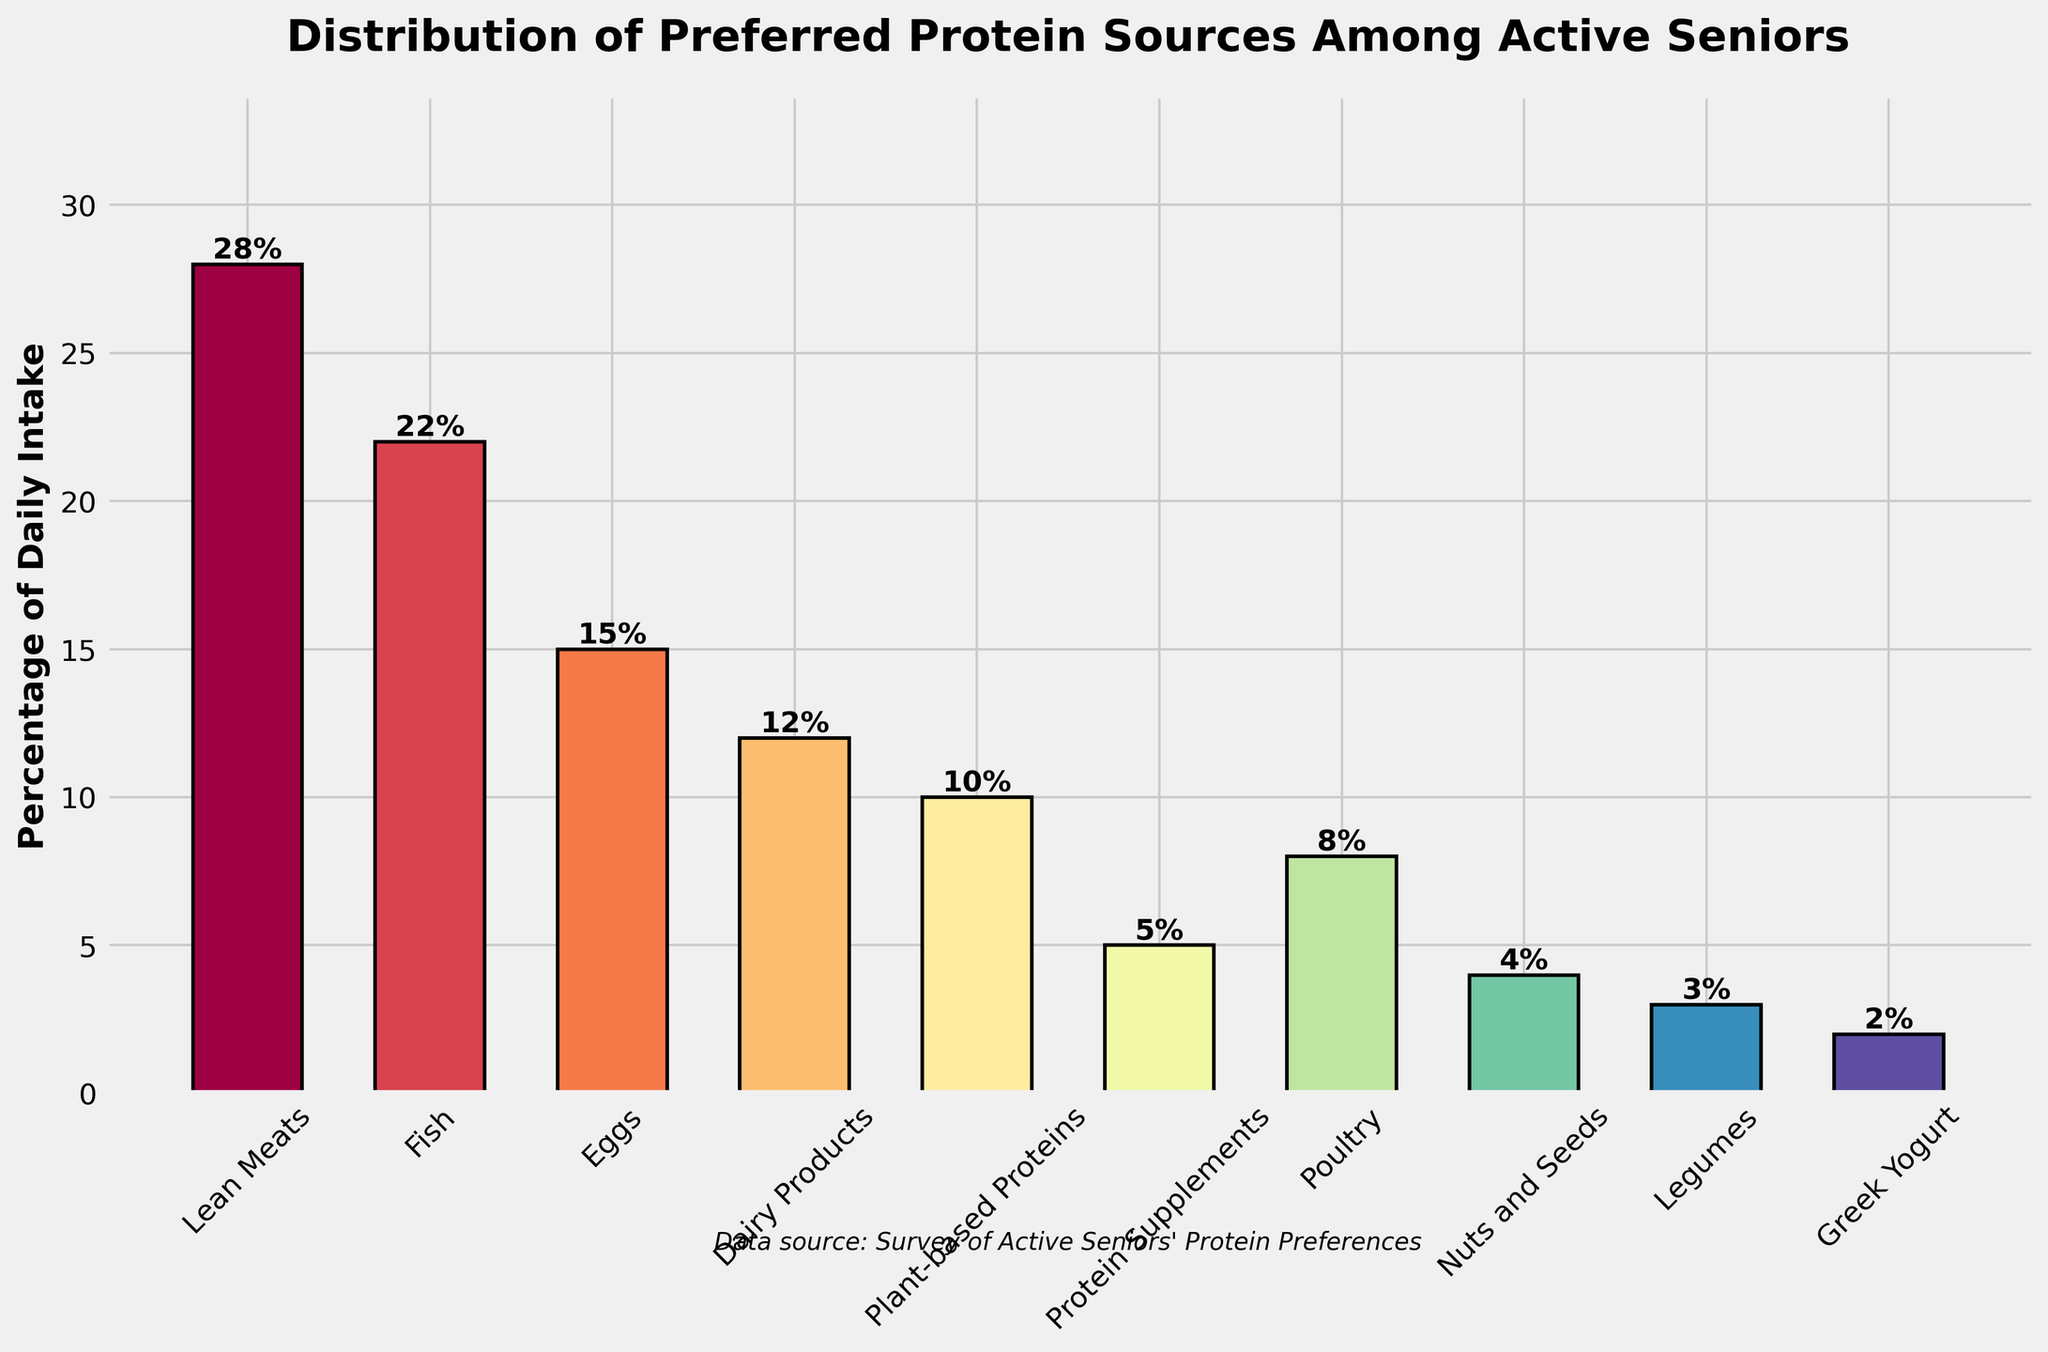What is the most preferred protein source among active seniors? The bar corresponding to 'Lean Meats' has the highest height and also displays the highest percentage value of 28%.
Answer: Lean Meats Which protein source has a higher percentage of daily intake, Fish or Eggs? By comparing the heights of the bars, 'Fish' has a percentage of 22%, while 'Eggs' has 15%. Therefore, 'Fish' has a higher percentage.
Answer: Fish What is the combined percentage of daily intake for Dairy Products, Plant-based Proteins, and Protein Supplements? The percentages are 12% for Dairy Products, 10% for Plant-based Proteins, and 5% for Protein Supplements. Summing these, 12 + 10 + 5 = 27%.
Answer: 27% Are Nuts and Seeds more or less preferred than Poultry? Comparing the heights and percentages, 'Nuts and Seeds' has a percentage of 4%, and 'Poultry' has 8%. Therefore, Nuts and Seeds are less preferred.
Answer: Less What is the median value of the daily intake percentages presented in the chart? Arrange the percentages in ascending order (2, 3, 4, 5, 8, 10, 12, 15, 22, 28). With 10 data points, the median is the average of the 5th and 6th values. The 5th and 6th values are 8 and 10, so (8 + 10)/2 = 9.
Answer: 9 Which protein source contributes less than 5% to the daily intake among active seniors? By examining the chart, 'Legumes' (3%) and 'Greek Yogurt' (2%) are the only sources contributing less than 5%.
Answer: Legumes, Greek Yogurt How much more does Fish contribute to the daily intake compared to Greek Yogurt? The percentage for Fish is 22% and for Greek Yogurt is 2%. Subtract 2 from 22: 22 - 2 = 20.
Answer: 20% Which protein sources have a daily intake percentage lower than Plant-based Proteins but higher than Legumes? The percentage of Plant-based Proteins is 10%, and Legumes is 3%. The sources with percentages between these values are Poultry (8%), Nuts and Seeds (4%), and Protein Supplements (5%).
Answer: Poultry, Nuts and Seeds, Protein Supplements Is the total daily intake percentage of Lean Meats, Fish, and Eggs more than or less than 60%? Summing the percentages: Lean Meats (28%), Fish (22%), and Eggs (15%) gives 28 + 22 + 15 = 65%.
Answer: More What color is used to represent Greek Yogurt on the plot? Greek Yogurt is represented by the last bar in the plot, which is colored based on the Spectral colormap. The color corresponding to Greek Yogurt is a shade close to purple.
Answer: Purple 